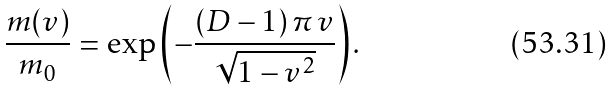Convert formula to latex. <formula><loc_0><loc_0><loc_500><loc_500>\frac { m ( v ) } { m _ { 0 } } = \exp \left ( - \frac { ( D - 1 ) \, \pi \, v } { \sqrt { 1 - v ^ { 2 } } } \right ) .</formula> 